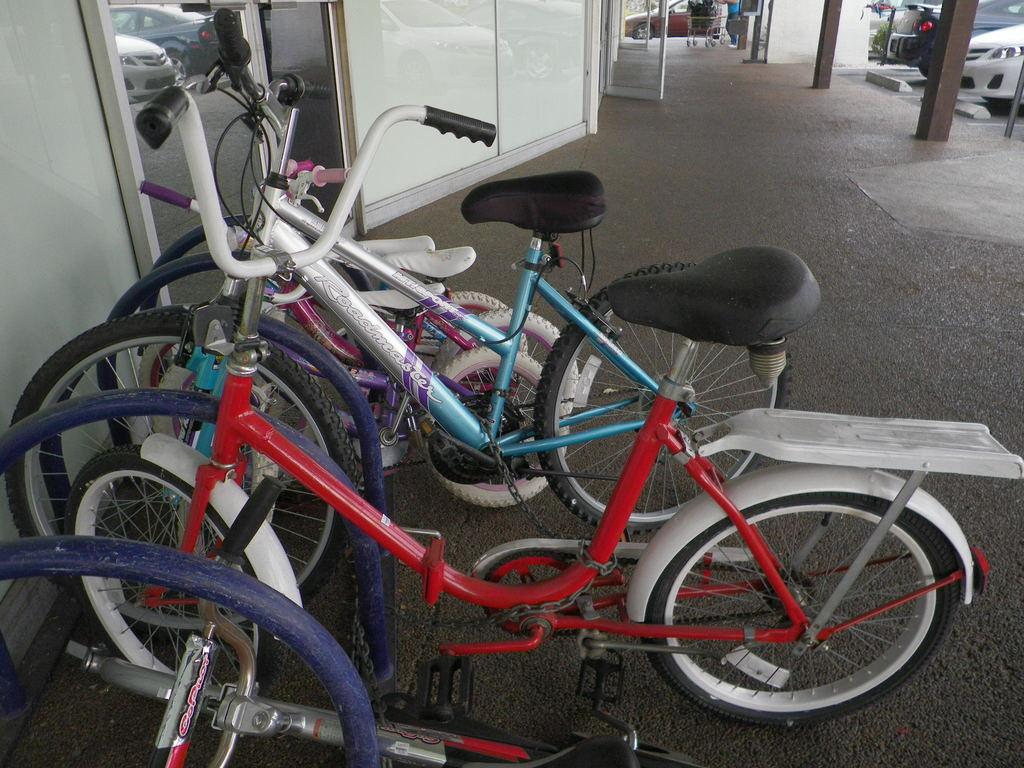What type of vehicles are present in the image? There are cycles and a car in the image. What object is near the cycles? There is a mirror near the cycles. What can be seen in the mirror? Cars are visible in the mirror. What architectural feature is at the top of the image? There is a door at the top of the image. What are the poles used for in the image? The purpose of the poles is not specified in the image. What type of team is depicted in the image? There is no team depicted in the image; it features cycles, a car, a mirror, a door, and poles. Is there a jail visible in the image? There is no jail present in the image. 